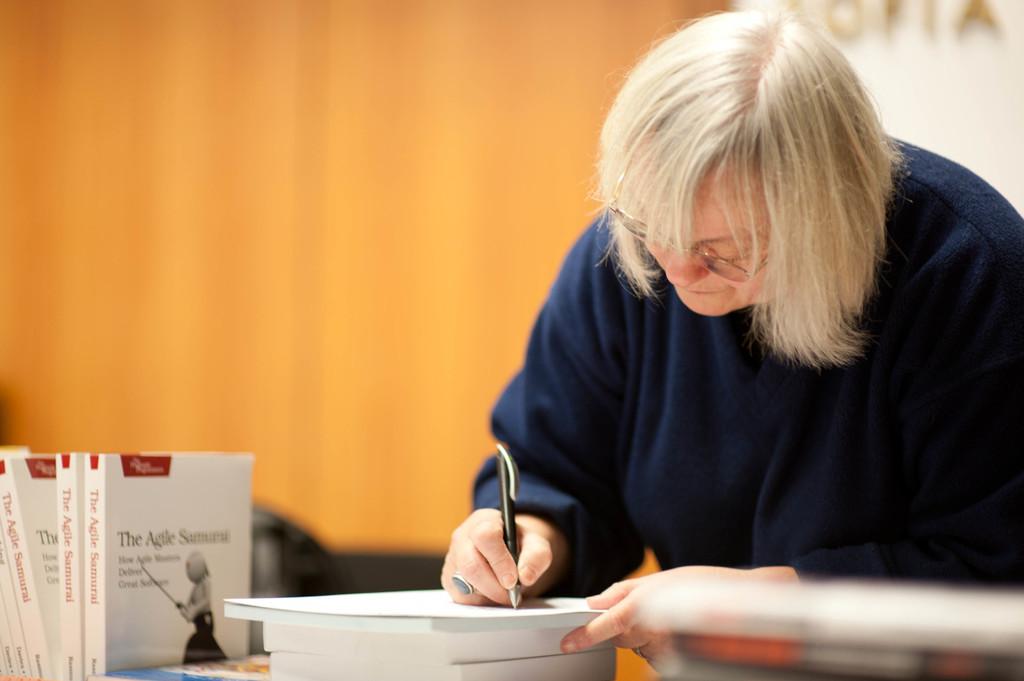What is the title of this author's novel?
Your answer should be very brief. The agile samurai. What is the first word under the title?
Offer a terse response. How. 